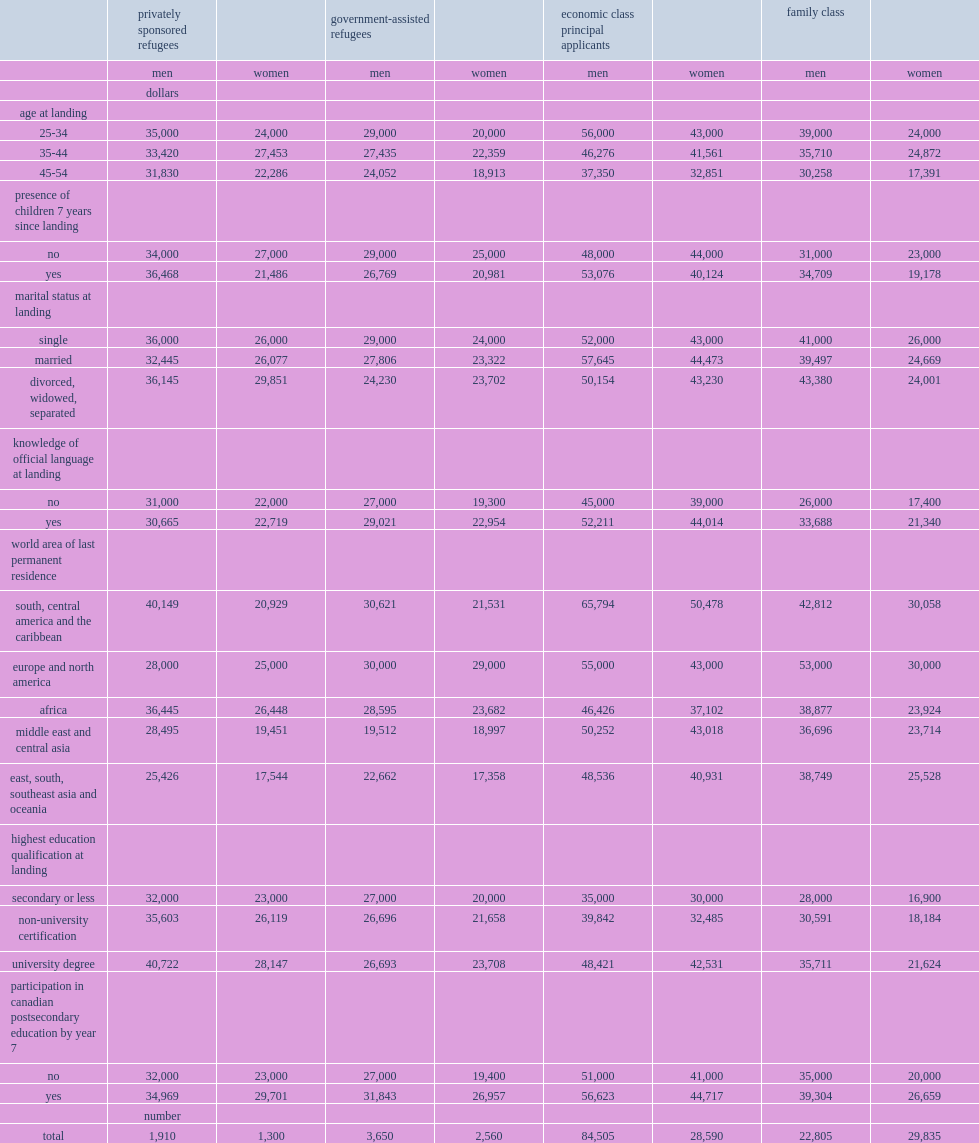What is the biggest difference in the adjusted average income of women with or without pse? 7557. What is the second big difference in the adjusted average income of women with or without pse? 6701. What is the third big difference in the adjusted average income of women with or without pse? 6659. What is the largest difference in the adjusted average income of men with or without pse? 5623. What is the second large difference in the adjusted average income of men with or without pse? 4843. What is the third large difference in the adjusted average income of men with or without pse? 4304. 